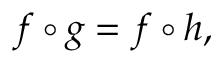<formula> <loc_0><loc_0><loc_500><loc_500>f \circ g = f \circ h ,</formula> 